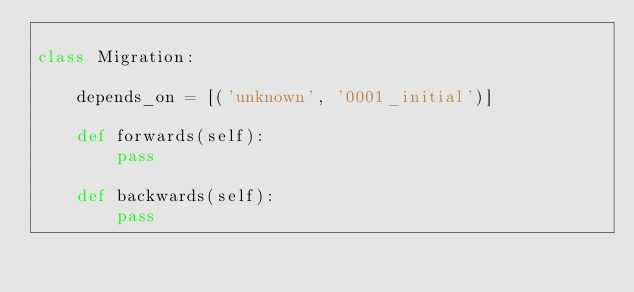Convert code to text. <code><loc_0><loc_0><loc_500><loc_500><_Python_>
class Migration:

    depends_on = [('unknown', '0001_initial')]
    
    def forwards(self):
        pass
    
    def backwards(self):
        pass

</code> 